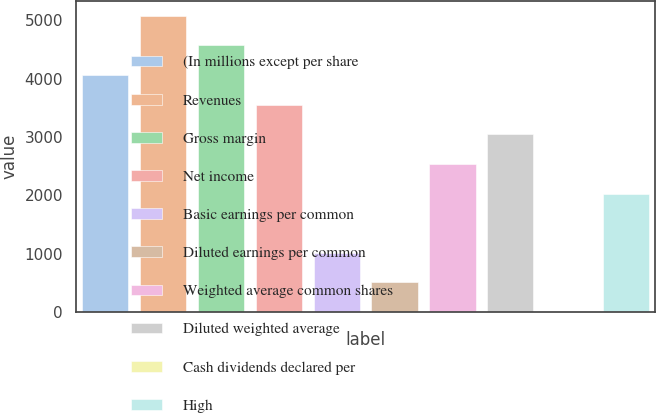Convert chart to OTSL. <chart><loc_0><loc_0><loc_500><loc_500><bar_chart><fcel>(In millions except per share<fcel>Revenues<fcel>Gross margin<fcel>Net income<fcel>Basic earnings per common<fcel>Diluted earnings per common<fcel>Weighted average common shares<fcel>Diluted weighted average<fcel>Cash dividends declared per<fcel>High<nl><fcel>4063.27<fcel>5079.01<fcel>4571.14<fcel>3555.4<fcel>1016.05<fcel>508.18<fcel>2539.66<fcel>3047.53<fcel>0.31<fcel>2031.79<nl></chart> 